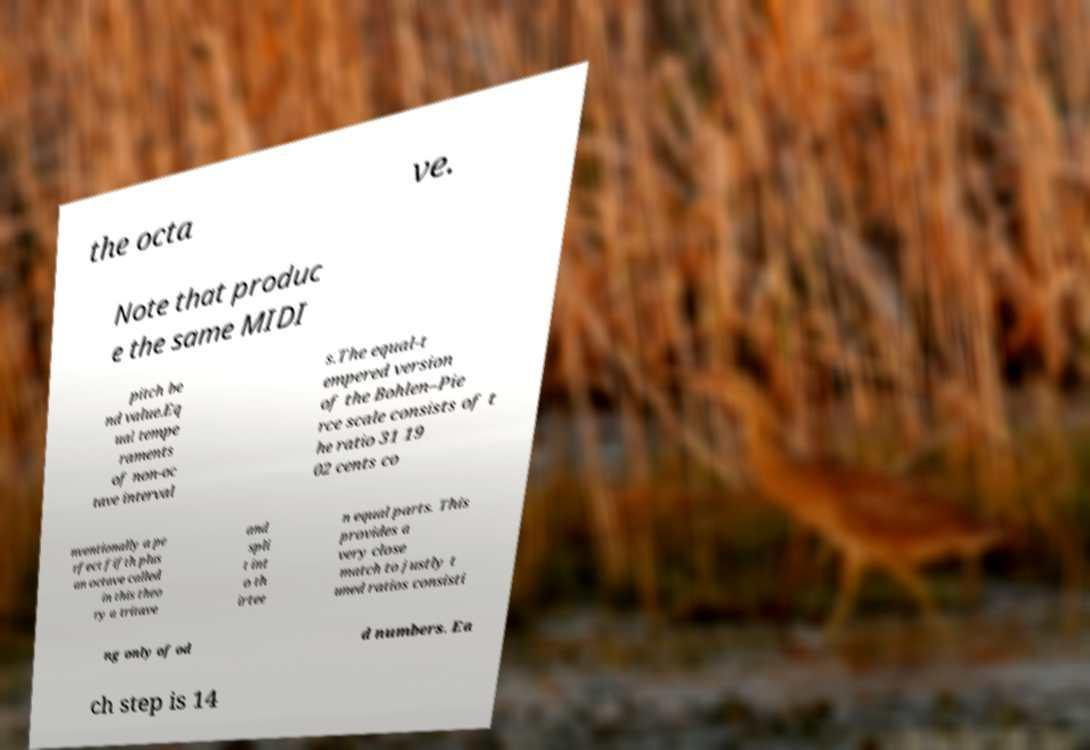There's text embedded in this image that I need extracted. Can you transcribe it verbatim? the octa ve. Note that produc e the same MIDI pitch be nd value.Eq ual tempe raments of non-oc tave interval s.The equal-t empered version of the Bohlen–Pie rce scale consists of t he ratio 31 19 02 cents co nventionally a pe rfect fifth plus an octave called in this theo ry a tritave and spli t int o th irtee n equal parts. This provides a very close match to justly t uned ratios consisti ng only of od d numbers. Ea ch step is 14 